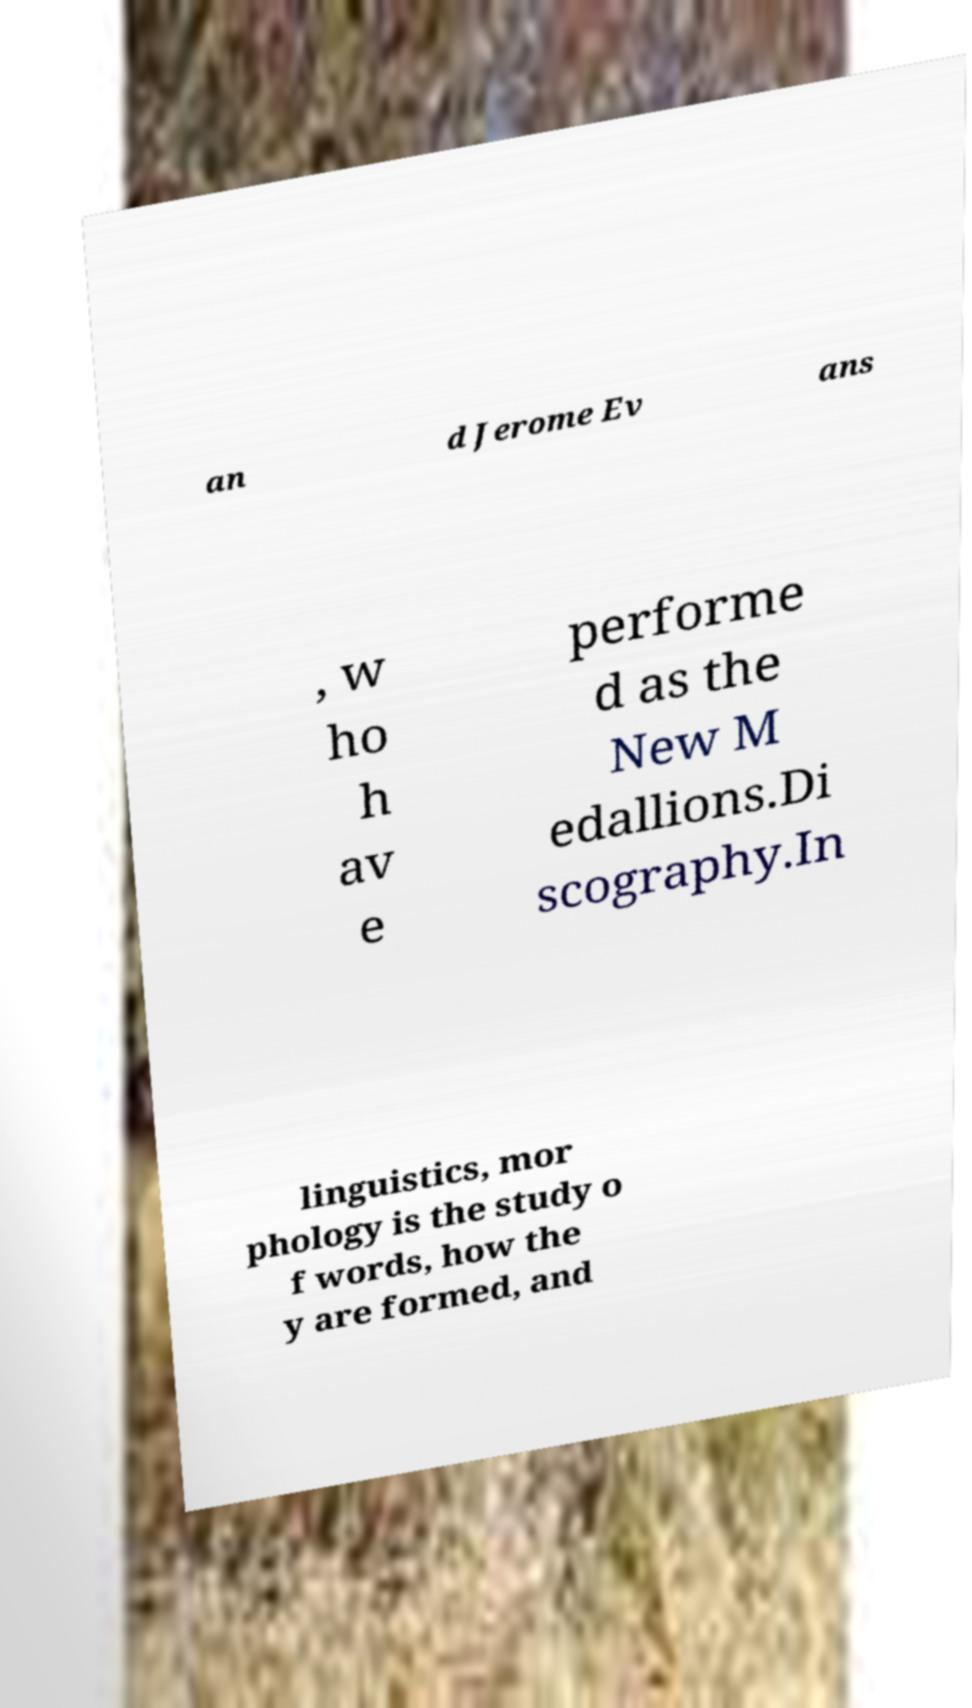Could you extract and type out the text from this image? an d Jerome Ev ans , w ho h av e performe d as the New M edallions.Di scography.In linguistics, mor phology is the study o f words, how the y are formed, and 